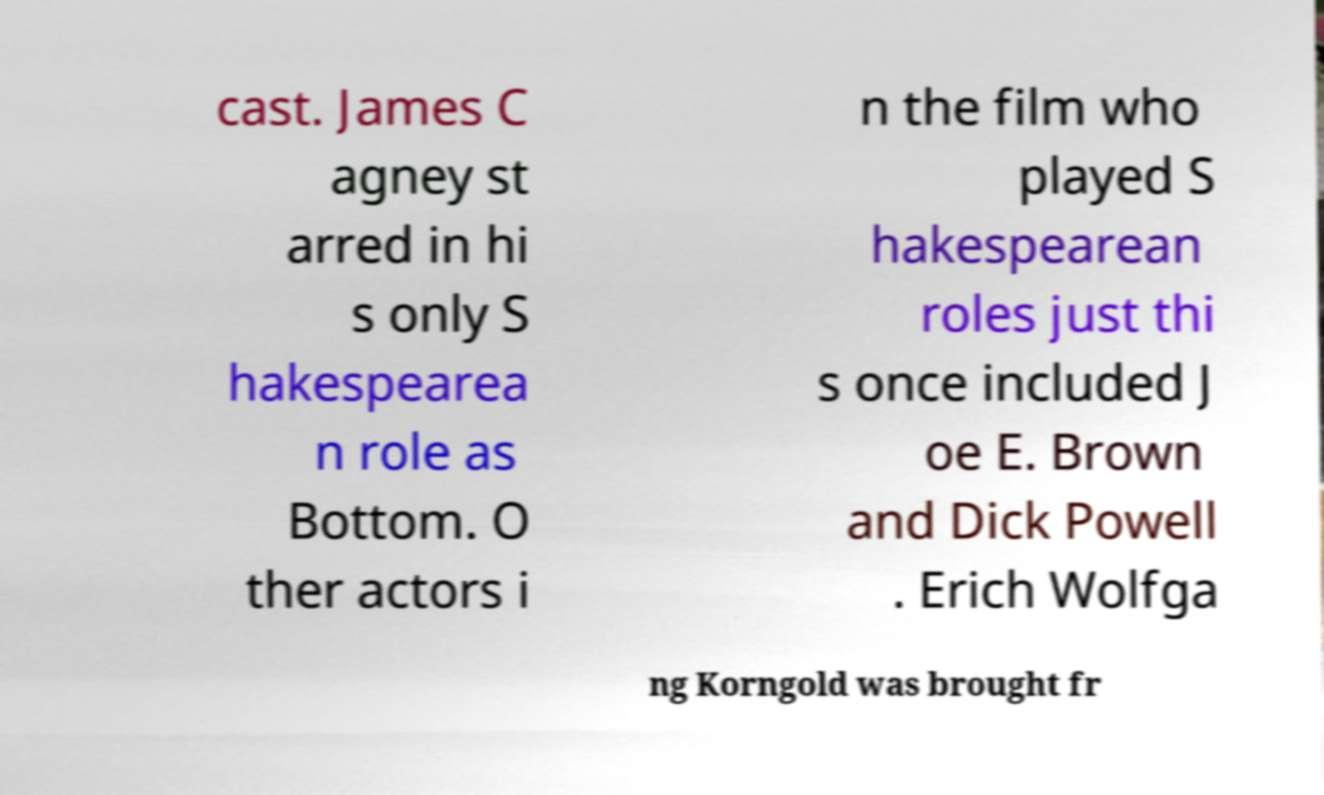There's text embedded in this image that I need extracted. Can you transcribe it verbatim? cast. James C agney st arred in hi s only S hakespearea n role as Bottom. O ther actors i n the film who played S hakespearean roles just thi s once included J oe E. Brown and Dick Powell . Erich Wolfga ng Korngold was brought fr 